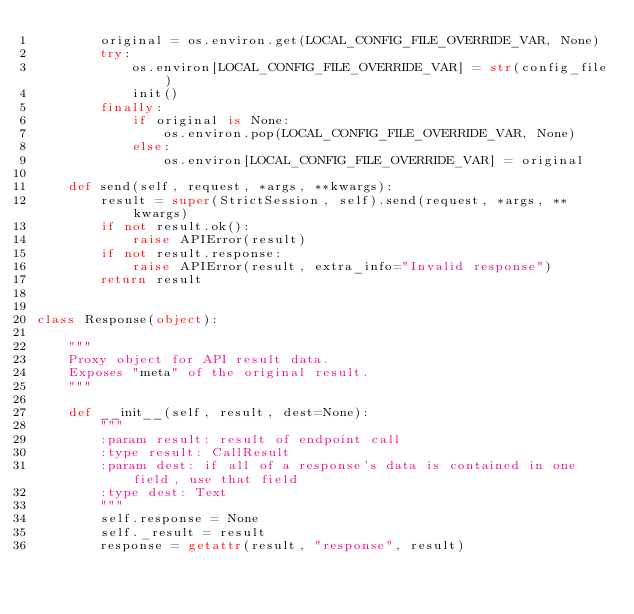<code> <loc_0><loc_0><loc_500><loc_500><_Python_>        original = os.environ.get(LOCAL_CONFIG_FILE_OVERRIDE_VAR, None)
        try:
            os.environ[LOCAL_CONFIG_FILE_OVERRIDE_VAR] = str(config_file)
            init()
        finally:
            if original is None:
                os.environ.pop(LOCAL_CONFIG_FILE_OVERRIDE_VAR, None)
            else:
                os.environ[LOCAL_CONFIG_FILE_OVERRIDE_VAR] = original

    def send(self, request, *args, **kwargs):
        result = super(StrictSession, self).send(request, *args, **kwargs)
        if not result.ok():
            raise APIError(result)
        if not result.response:
            raise APIError(result, extra_info="Invalid response")
        return result


class Response(object):

    """
    Proxy object for API result data.
    Exposes "meta" of the original result.
    """

    def __init__(self, result, dest=None):
        """
        :param result: result of endpoint call
        :type result: CallResult
        :param dest: if all of a response's data is contained in one field, use that field
        :type dest: Text
        """
        self.response = None
        self._result = result
        response = getattr(result, "response", result)</code> 